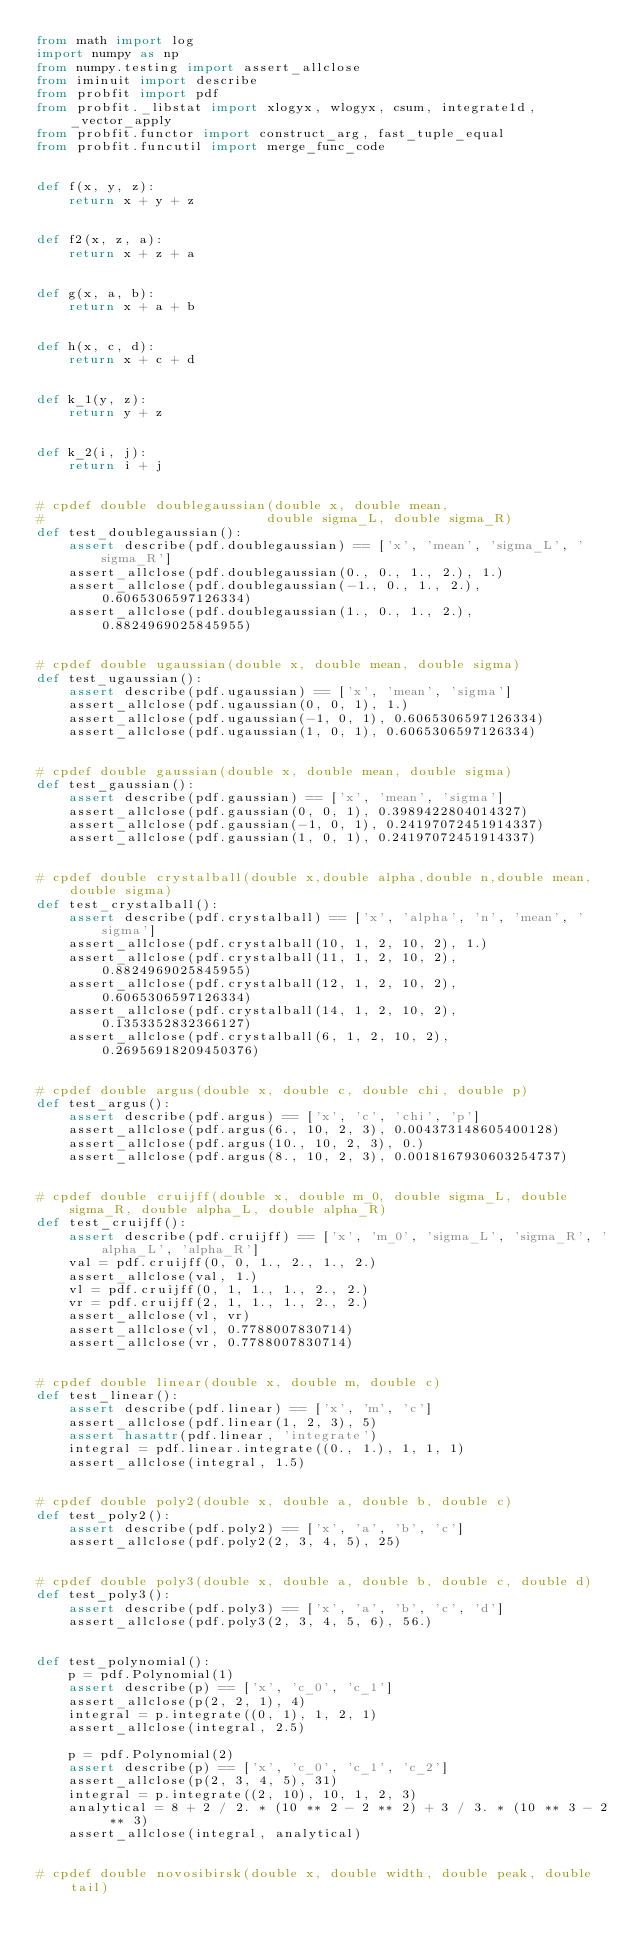Convert code to text. <code><loc_0><loc_0><loc_500><loc_500><_Python_>from math import log
import numpy as np
from numpy.testing import assert_allclose
from iminuit import describe
from probfit import pdf
from probfit._libstat import xlogyx, wlogyx, csum, integrate1d, _vector_apply
from probfit.functor import construct_arg, fast_tuple_equal
from probfit.funcutil import merge_func_code


def f(x, y, z):
    return x + y + z


def f2(x, z, a):
    return x + z + a


def g(x, a, b):
    return x + a + b


def h(x, c, d):
    return x + c + d


def k_1(y, z):
    return y + z


def k_2(i, j):
    return i + j


# cpdef double doublegaussian(double x, double mean,
#                            double sigma_L, double sigma_R)
def test_doublegaussian():
    assert describe(pdf.doublegaussian) == ['x', 'mean', 'sigma_L', 'sigma_R']
    assert_allclose(pdf.doublegaussian(0., 0., 1., 2.), 1.)
    assert_allclose(pdf.doublegaussian(-1., 0., 1., 2.), 0.6065306597126334)
    assert_allclose(pdf.doublegaussian(1., 0., 1., 2.), 0.8824969025845955)


# cpdef double ugaussian(double x, double mean, double sigma)
def test_ugaussian():
    assert describe(pdf.ugaussian) == ['x', 'mean', 'sigma']
    assert_allclose(pdf.ugaussian(0, 0, 1), 1.)
    assert_allclose(pdf.ugaussian(-1, 0, 1), 0.6065306597126334)
    assert_allclose(pdf.ugaussian(1, 0, 1), 0.6065306597126334)


# cpdef double gaussian(double x, double mean, double sigma)
def test_gaussian():
    assert describe(pdf.gaussian) == ['x', 'mean', 'sigma']
    assert_allclose(pdf.gaussian(0, 0, 1), 0.3989422804014327)
    assert_allclose(pdf.gaussian(-1, 0, 1), 0.24197072451914337)
    assert_allclose(pdf.gaussian(1, 0, 1), 0.24197072451914337)


# cpdef double crystalball(double x,double alpha,double n,double mean,double sigma)
def test_crystalball():
    assert describe(pdf.crystalball) == ['x', 'alpha', 'n', 'mean', 'sigma']
    assert_allclose(pdf.crystalball(10, 1, 2, 10, 2), 1.)
    assert_allclose(pdf.crystalball(11, 1, 2, 10, 2), 0.8824969025845955)
    assert_allclose(pdf.crystalball(12, 1, 2, 10, 2), 0.6065306597126334)
    assert_allclose(pdf.crystalball(14, 1, 2, 10, 2), 0.1353352832366127)
    assert_allclose(pdf.crystalball(6, 1, 2, 10, 2), 0.26956918209450376)


# cpdef double argus(double x, double c, double chi, double p)
def test_argus():
    assert describe(pdf.argus) == ['x', 'c', 'chi', 'p']
    assert_allclose(pdf.argus(6., 10, 2, 3), 0.004373148605400128)
    assert_allclose(pdf.argus(10., 10, 2, 3), 0.)
    assert_allclose(pdf.argus(8., 10, 2, 3), 0.0018167930603254737)


# cpdef double cruijff(double x, double m_0, double sigma_L, double sigma_R, double alpha_L, double alpha_R)
def test_cruijff():
    assert describe(pdf.cruijff) == ['x', 'm_0', 'sigma_L', 'sigma_R', 'alpha_L', 'alpha_R']
    val = pdf.cruijff(0, 0, 1., 2., 1., 2.)
    assert_allclose(val, 1.)
    vl = pdf.cruijff(0, 1, 1., 1., 2., 2.)
    vr = pdf.cruijff(2, 1, 1., 1., 2., 2.)
    assert_allclose(vl, vr)
    assert_allclose(vl, 0.7788007830714)
    assert_allclose(vr, 0.7788007830714)


# cpdef double linear(double x, double m, double c)
def test_linear():
    assert describe(pdf.linear) == ['x', 'm', 'c']
    assert_allclose(pdf.linear(1, 2, 3), 5)
    assert hasattr(pdf.linear, 'integrate')
    integral = pdf.linear.integrate((0., 1.), 1, 1, 1)
    assert_allclose(integral, 1.5)


# cpdef double poly2(double x, double a, double b, double c)
def test_poly2():
    assert describe(pdf.poly2) == ['x', 'a', 'b', 'c']
    assert_allclose(pdf.poly2(2, 3, 4, 5), 25)


# cpdef double poly3(double x, double a, double b, double c, double d)
def test_poly3():
    assert describe(pdf.poly3) == ['x', 'a', 'b', 'c', 'd']
    assert_allclose(pdf.poly3(2, 3, 4, 5, 6), 56.)


def test_polynomial():
    p = pdf.Polynomial(1)
    assert describe(p) == ['x', 'c_0', 'c_1']
    assert_allclose(p(2, 2, 1), 4)
    integral = p.integrate((0, 1), 1, 2, 1)
    assert_allclose(integral, 2.5)

    p = pdf.Polynomial(2)
    assert describe(p) == ['x', 'c_0', 'c_1', 'c_2']
    assert_allclose(p(2, 3, 4, 5), 31)
    integral = p.integrate((2, 10), 10, 1, 2, 3)
    analytical = 8 + 2 / 2. * (10 ** 2 - 2 ** 2) + 3 / 3. * (10 ** 3 - 2 ** 3)
    assert_allclose(integral, analytical)


# cpdef double novosibirsk(double x, double width, double peak, double tail)</code> 